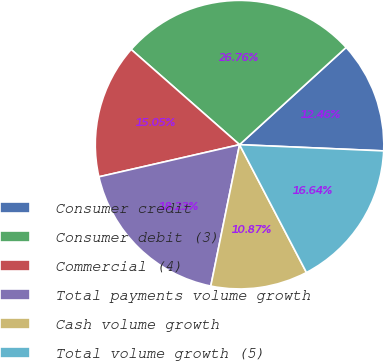Convert chart to OTSL. <chart><loc_0><loc_0><loc_500><loc_500><pie_chart><fcel>Consumer credit<fcel>Consumer debit (3)<fcel>Commercial (4)<fcel>Total payments volume growth<fcel>Cash volume growth<fcel>Total volume growth (5)<nl><fcel>12.46%<fcel>26.76%<fcel>15.05%<fcel>18.23%<fcel>10.87%<fcel>16.64%<nl></chart> 